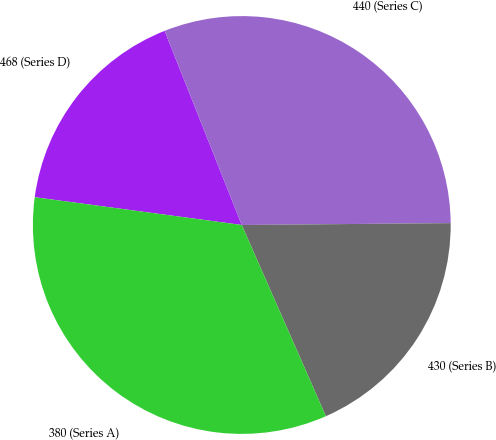<chart> <loc_0><loc_0><loc_500><loc_500><pie_chart><fcel>468 (Series D)<fcel>440 (Series C)<fcel>430 (Series B)<fcel>380 (Series A)<nl><fcel>16.86%<fcel>30.88%<fcel>18.55%<fcel>33.72%<nl></chart> 